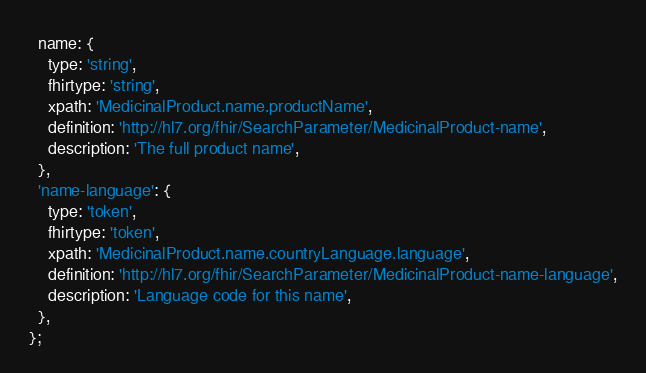<code> <loc_0><loc_0><loc_500><loc_500><_JavaScript_>  name: {
    type: 'string',
    fhirtype: 'string',
    xpath: 'MedicinalProduct.name.productName',
    definition: 'http://hl7.org/fhir/SearchParameter/MedicinalProduct-name',
    description: 'The full product name',
  },
  'name-language': {
    type: 'token',
    fhirtype: 'token',
    xpath: 'MedicinalProduct.name.countryLanguage.language',
    definition: 'http://hl7.org/fhir/SearchParameter/MedicinalProduct-name-language',
    description: 'Language code for this name',
  },
};
</code> 